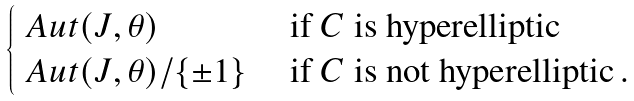Convert formula to latex. <formula><loc_0><loc_0><loc_500><loc_500>\begin{cases} \ A u t ( J , \theta ) & \text { if $C$ is hyperelliptic} \\ \ A u t ( J , \theta ) / \{ \pm 1 \} & \text { if $C$ is not hyperelliptic} \, . \end{cases}</formula> 